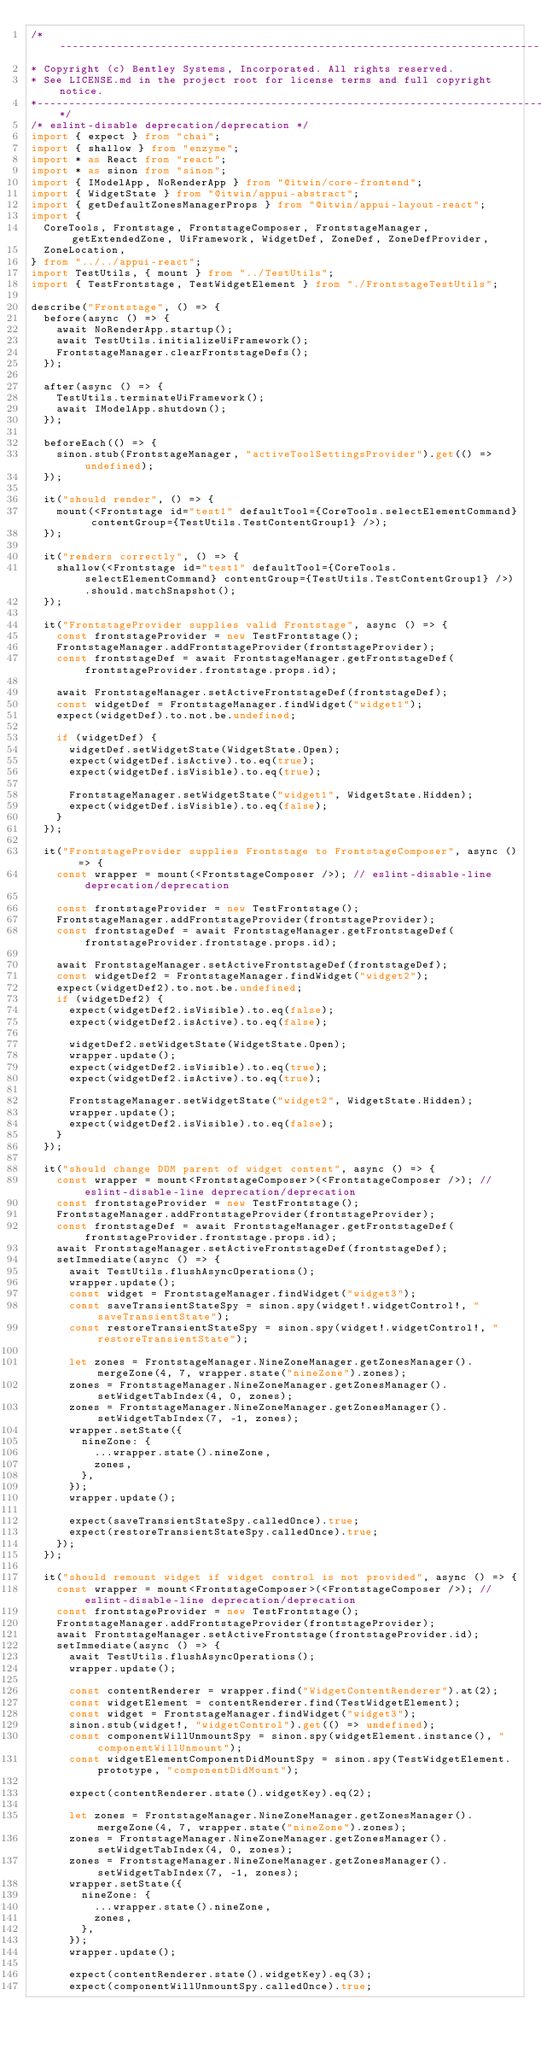Convert code to text. <code><loc_0><loc_0><loc_500><loc_500><_TypeScript_>/*---------------------------------------------------------------------------------------------
* Copyright (c) Bentley Systems, Incorporated. All rights reserved.
* See LICENSE.md in the project root for license terms and full copyright notice.
*--------------------------------------------------------------------------------------------*/
/* eslint-disable deprecation/deprecation */
import { expect } from "chai";
import { shallow } from "enzyme";
import * as React from "react";
import * as sinon from "sinon";
import { IModelApp, NoRenderApp } from "@itwin/core-frontend";
import { WidgetState } from "@itwin/appui-abstract";
import { getDefaultZonesManagerProps } from "@itwin/appui-layout-react";
import {
  CoreTools, Frontstage, FrontstageComposer, FrontstageManager, getExtendedZone, UiFramework, WidgetDef, ZoneDef, ZoneDefProvider,
  ZoneLocation,
} from "../../appui-react";
import TestUtils, { mount } from "../TestUtils";
import { TestFrontstage, TestWidgetElement } from "./FrontstageTestUtils";

describe("Frontstage", () => {
  before(async () => {
    await NoRenderApp.startup();
    await TestUtils.initializeUiFramework();
    FrontstageManager.clearFrontstageDefs();
  });

  after(async () => {
    TestUtils.terminateUiFramework();
    await IModelApp.shutdown();
  });

  beforeEach(() => {
    sinon.stub(FrontstageManager, "activeToolSettingsProvider").get(() => undefined);
  });

  it("should render", () => {
    mount(<Frontstage id="test1" defaultTool={CoreTools.selectElementCommand} contentGroup={TestUtils.TestContentGroup1} />);
  });

  it("renders correctly", () => {
    shallow(<Frontstage id="test1" defaultTool={CoreTools.selectElementCommand} contentGroup={TestUtils.TestContentGroup1} />).should.matchSnapshot();
  });

  it("FrontstageProvider supplies valid Frontstage", async () => {
    const frontstageProvider = new TestFrontstage();
    FrontstageManager.addFrontstageProvider(frontstageProvider);
    const frontstageDef = await FrontstageManager.getFrontstageDef(frontstageProvider.frontstage.props.id);

    await FrontstageManager.setActiveFrontstageDef(frontstageDef);
    const widgetDef = FrontstageManager.findWidget("widget1");
    expect(widgetDef).to.not.be.undefined;

    if (widgetDef) {
      widgetDef.setWidgetState(WidgetState.Open);
      expect(widgetDef.isActive).to.eq(true);
      expect(widgetDef.isVisible).to.eq(true);

      FrontstageManager.setWidgetState("widget1", WidgetState.Hidden);
      expect(widgetDef.isVisible).to.eq(false);
    }
  });

  it("FrontstageProvider supplies Frontstage to FrontstageComposer", async () => {
    const wrapper = mount(<FrontstageComposer />); // eslint-disable-line deprecation/deprecation

    const frontstageProvider = new TestFrontstage();
    FrontstageManager.addFrontstageProvider(frontstageProvider);
    const frontstageDef = await FrontstageManager.getFrontstageDef(frontstageProvider.frontstage.props.id);

    await FrontstageManager.setActiveFrontstageDef(frontstageDef);
    const widgetDef2 = FrontstageManager.findWidget("widget2");
    expect(widgetDef2).to.not.be.undefined;
    if (widgetDef2) {
      expect(widgetDef2.isVisible).to.eq(false);
      expect(widgetDef2.isActive).to.eq(false);

      widgetDef2.setWidgetState(WidgetState.Open);
      wrapper.update();
      expect(widgetDef2.isVisible).to.eq(true);
      expect(widgetDef2.isActive).to.eq(true);

      FrontstageManager.setWidgetState("widget2", WidgetState.Hidden);
      wrapper.update();
      expect(widgetDef2.isVisible).to.eq(false);
    }
  });

  it("should change DOM parent of widget content", async () => {
    const wrapper = mount<FrontstageComposer>(<FrontstageComposer />); // eslint-disable-line deprecation/deprecation
    const frontstageProvider = new TestFrontstage();
    FrontstageManager.addFrontstageProvider(frontstageProvider);
    const frontstageDef = await FrontstageManager.getFrontstageDef(frontstageProvider.frontstage.props.id);
    await FrontstageManager.setActiveFrontstageDef(frontstageDef);
    setImmediate(async () => {
      await TestUtils.flushAsyncOperations();
      wrapper.update();
      const widget = FrontstageManager.findWidget("widget3");
      const saveTransientStateSpy = sinon.spy(widget!.widgetControl!, "saveTransientState");
      const restoreTransientStateSpy = sinon.spy(widget!.widgetControl!, "restoreTransientState");

      let zones = FrontstageManager.NineZoneManager.getZonesManager().mergeZone(4, 7, wrapper.state("nineZone").zones);
      zones = FrontstageManager.NineZoneManager.getZonesManager().setWidgetTabIndex(4, 0, zones);
      zones = FrontstageManager.NineZoneManager.getZonesManager().setWidgetTabIndex(7, -1, zones);
      wrapper.setState({
        nineZone: {
          ...wrapper.state().nineZone,
          zones,
        },
      });
      wrapper.update();

      expect(saveTransientStateSpy.calledOnce).true;
      expect(restoreTransientStateSpy.calledOnce).true;
    });
  });

  it("should remount widget if widget control is not provided", async () => {
    const wrapper = mount<FrontstageComposer>(<FrontstageComposer />); // eslint-disable-line deprecation/deprecation
    const frontstageProvider = new TestFrontstage();
    FrontstageManager.addFrontstageProvider(frontstageProvider);
    await FrontstageManager.setActiveFrontstage(frontstageProvider.id);
    setImmediate(async () => {
      await TestUtils.flushAsyncOperations();
      wrapper.update();

      const contentRenderer = wrapper.find("WidgetContentRenderer").at(2);
      const widgetElement = contentRenderer.find(TestWidgetElement);
      const widget = FrontstageManager.findWidget("widget3");
      sinon.stub(widget!, "widgetControl").get(() => undefined);
      const componentWillUnmountSpy = sinon.spy(widgetElement.instance(), "componentWillUnmount");
      const widgetElementComponentDidMountSpy = sinon.spy(TestWidgetElement.prototype, "componentDidMount");

      expect(contentRenderer.state().widgetKey).eq(2);

      let zones = FrontstageManager.NineZoneManager.getZonesManager().mergeZone(4, 7, wrapper.state("nineZone").zones);
      zones = FrontstageManager.NineZoneManager.getZonesManager().setWidgetTabIndex(4, 0, zones);
      zones = FrontstageManager.NineZoneManager.getZonesManager().setWidgetTabIndex(7, -1, zones);
      wrapper.setState({
        nineZone: {
          ...wrapper.state().nineZone,
          zones,
        },
      });
      wrapper.update();

      expect(contentRenderer.state().widgetKey).eq(3);
      expect(componentWillUnmountSpy.calledOnce).true;</code> 